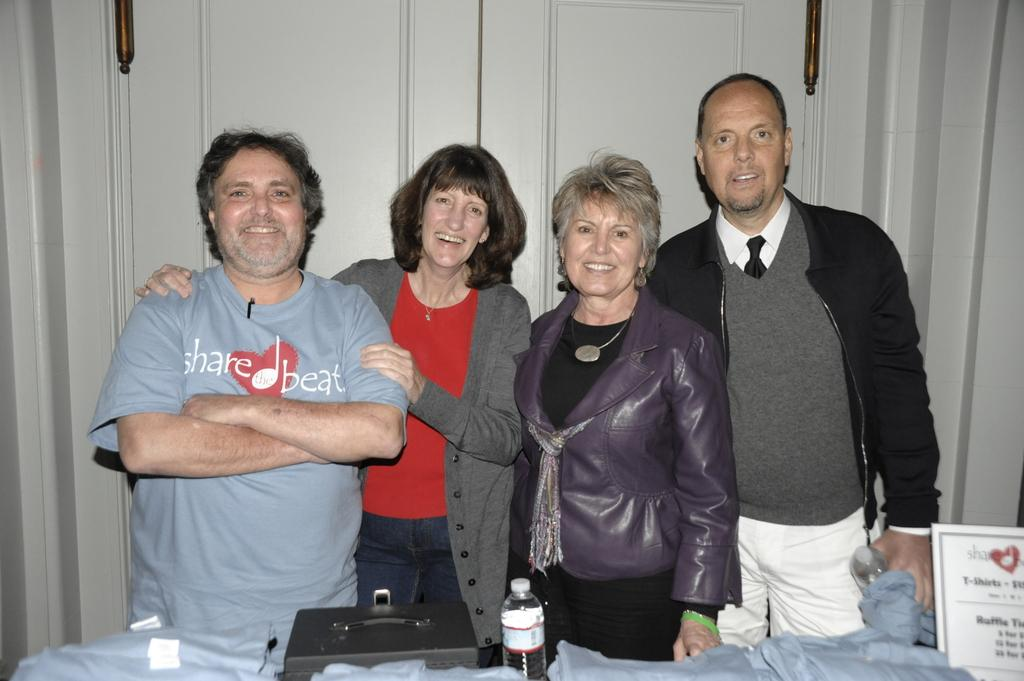How many people are in the image? There are four people in the image. What are the people doing in the image? The people are standing and smiling. What objects are in front of the people? There are bottles, a name board, a box, and clothes in front of the people. What can be seen at the back of the people? There are doors visible at the back of the people. What type of volleyball game is being played in the image? There is no volleyball game present in the image. How many eyes can be seen on the people in the image? It is not possible to count the exact number of eyes on the people in the image, as their faces are not clearly visible. --- 